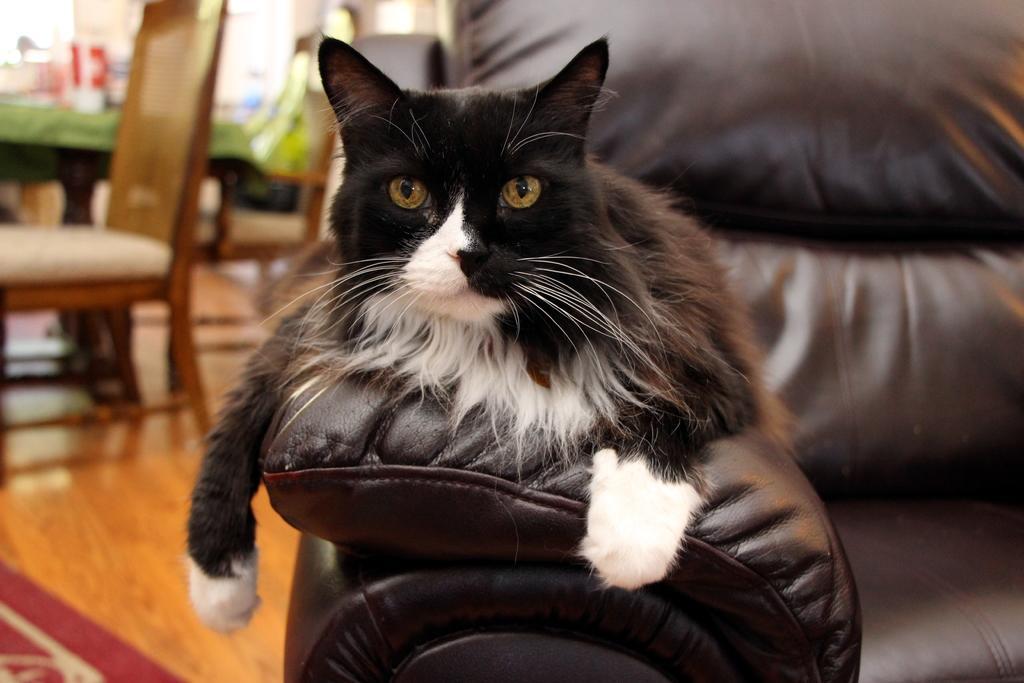Can you describe this image briefly? In this image, we can see cat is sat on the couch. At the background, we can see wooden table, chairs. Few items are placed on the green color cloth. And floor at the bottom. 